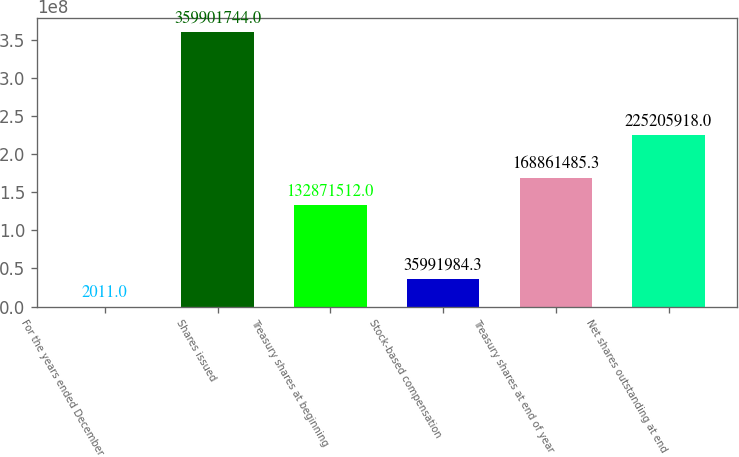Convert chart to OTSL. <chart><loc_0><loc_0><loc_500><loc_500><bar_chart><fcel>For the years ended December<fcel>Shares issued<fcel>Treasury shares at beginning<fcel>Stock-based compensation<fcel>Treasury shares at end of year<fcel>Net shares outstanding at end<nl><fcel>2011<fcel>3.59902e+08<fcel>1.32872e+08<fcel>3.5992e+07<fcel>1.68861e+08<fcel>2.25206e+08<nl></chart> 